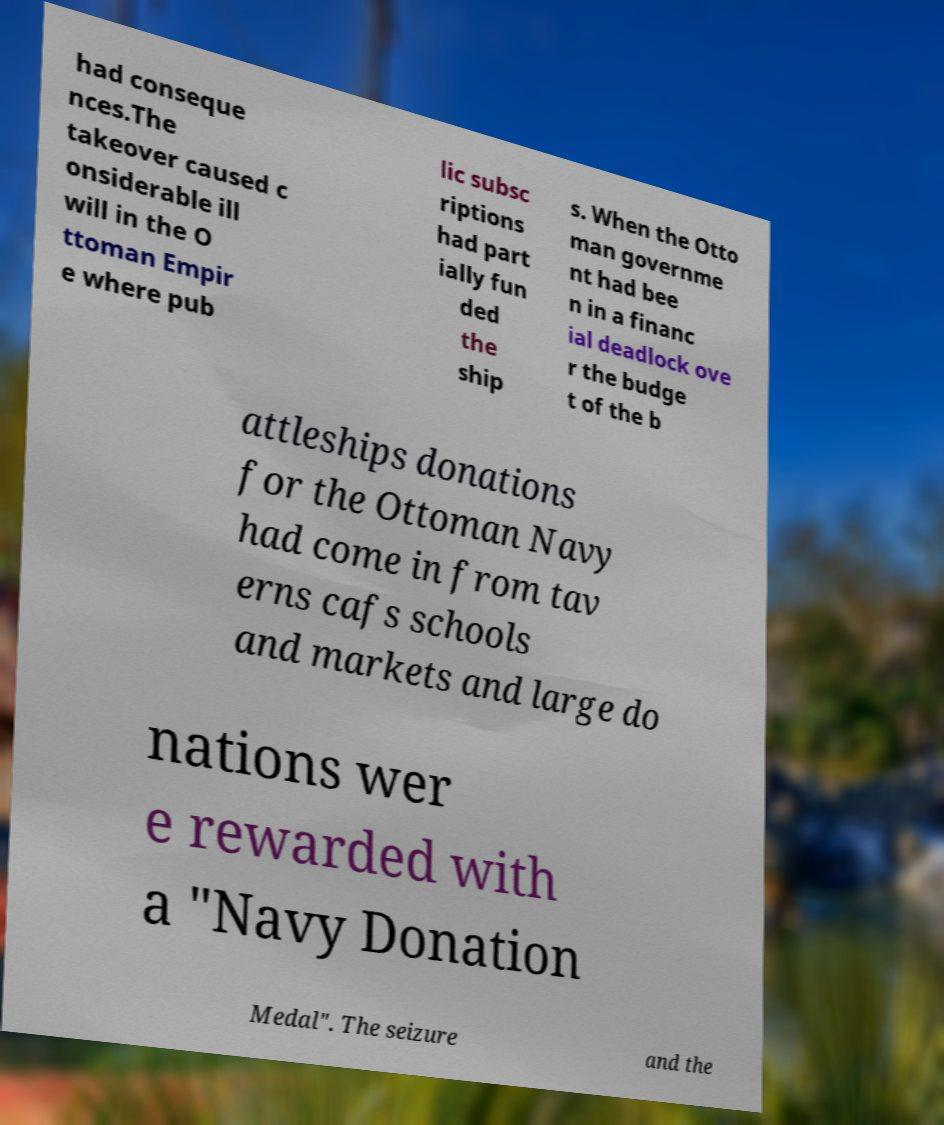There's text embedded in this image that I need extracted. Can you transcribe it verbatim? had conseque nces.The takeover caused c onsiderable ill will in the O ttoman Empir e where pub lic subsc riptions had part ially fun ded the ship s. When the Otto man governme nt had bee n in a financ ial deadlock ove r the budge t of the b attleships donations for the Ottoman Navy had come in from tav erns cafs schools and markets and large do nations wer e rewarded with a "Navy Donation Medal". The seizure and the 